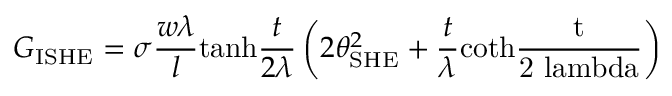Convert formula to latex. <formula><loc_0><loc_0><loc_500><loc_500>G _ { I S H E } = \sigma \frac { w \lambda } { l } t a n h \frac { t } { 2 \lambda } \left ( 2 \theta _ { S H E } ^ { 2 } + \frac { t } { \lambda } c o t h \frac { t } { 2 \ l a m b d a } \right )</formula> 